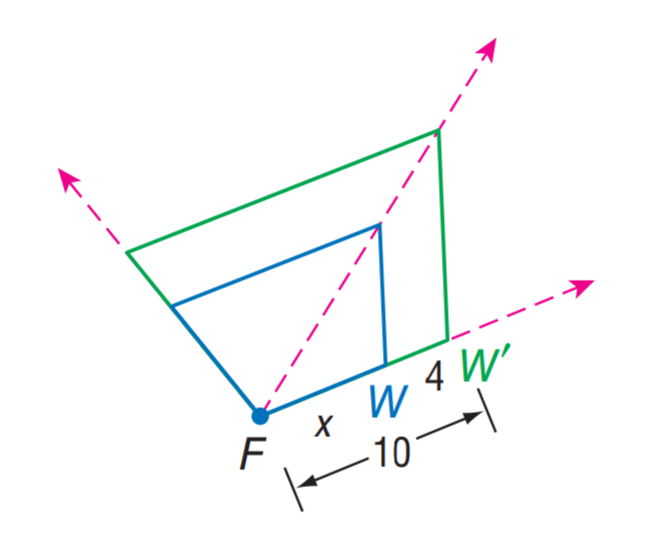Question: Find the scale factor from W to W'.
Choices:
A. 0.4
B. 0.6
C. 0.8
D. 1
Answer with the letter. Answer: B Question: Find x.
Choices:
A. 4
B. 6
C. 8
D. 10
Answer with the letter. Answer: B 